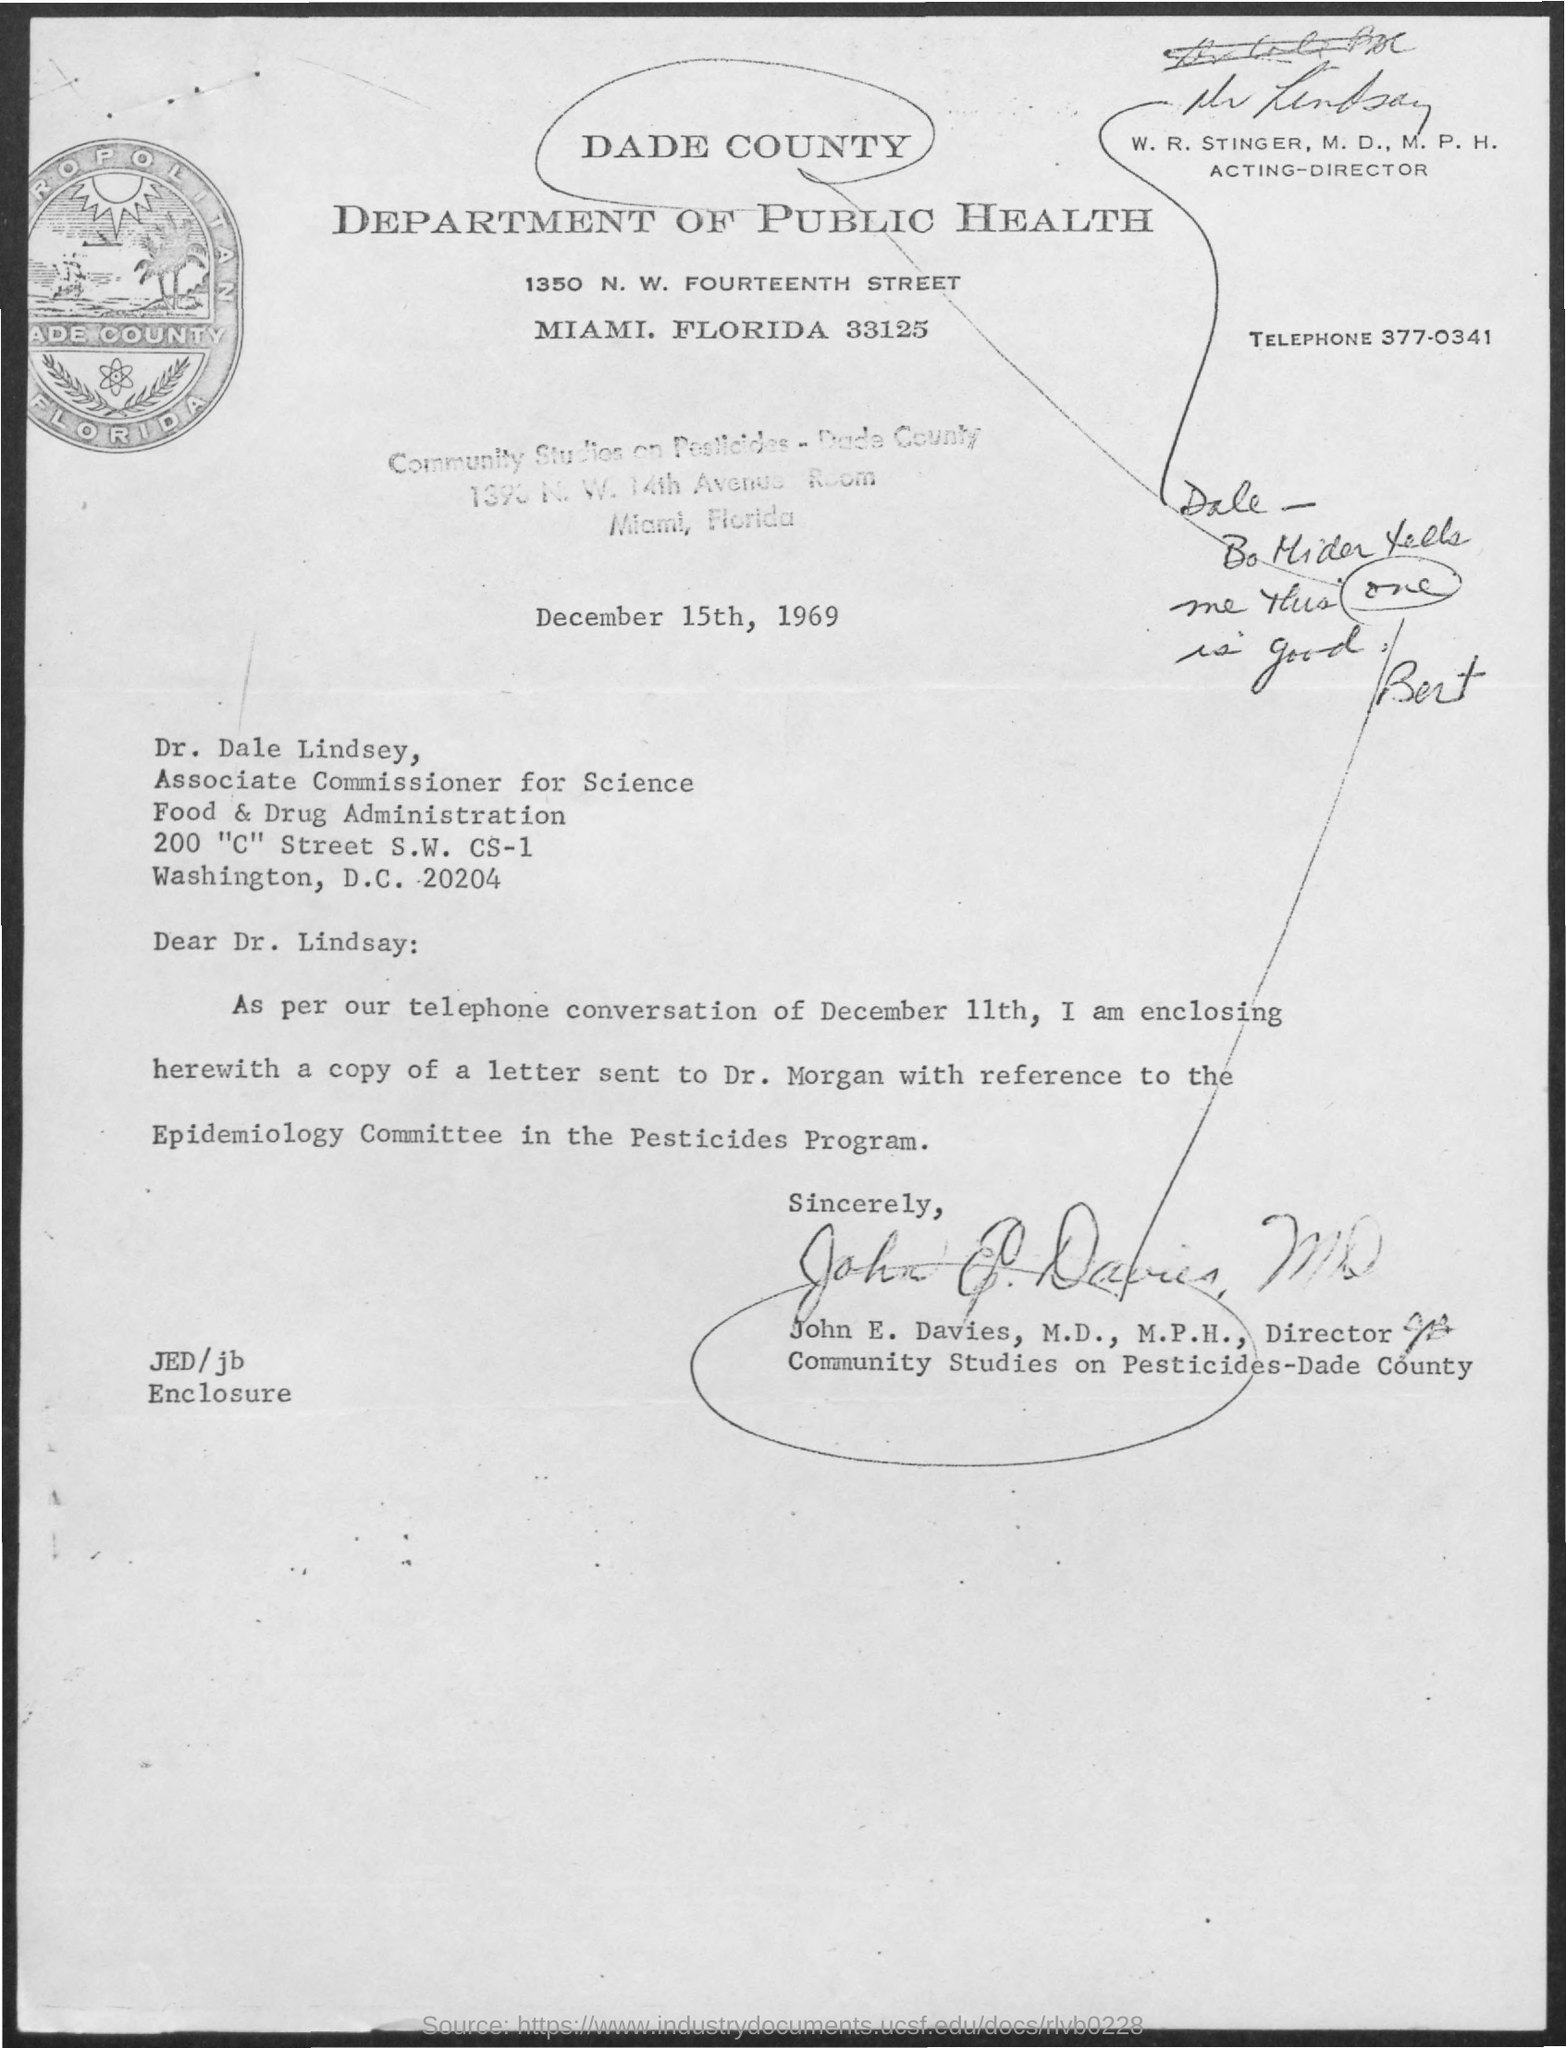What is the name of the department mentioned in the given letter ?
Make the answer very short. Department of public health. What is the date mentioned in the given letter ?
Your response must be concise. December 15th, 1969. What is the telephone number mentioned in the given letter ?
Provide a succinct answer. 377-0341. What is the designation of w.r.stinger mentioned in the given letter ?
Your answer should be compact. Acting-director. What is the designation of dr. dale lindsey as mentioned in the given letter ?
Provide a succinct answer. Associate commissioner for science. 